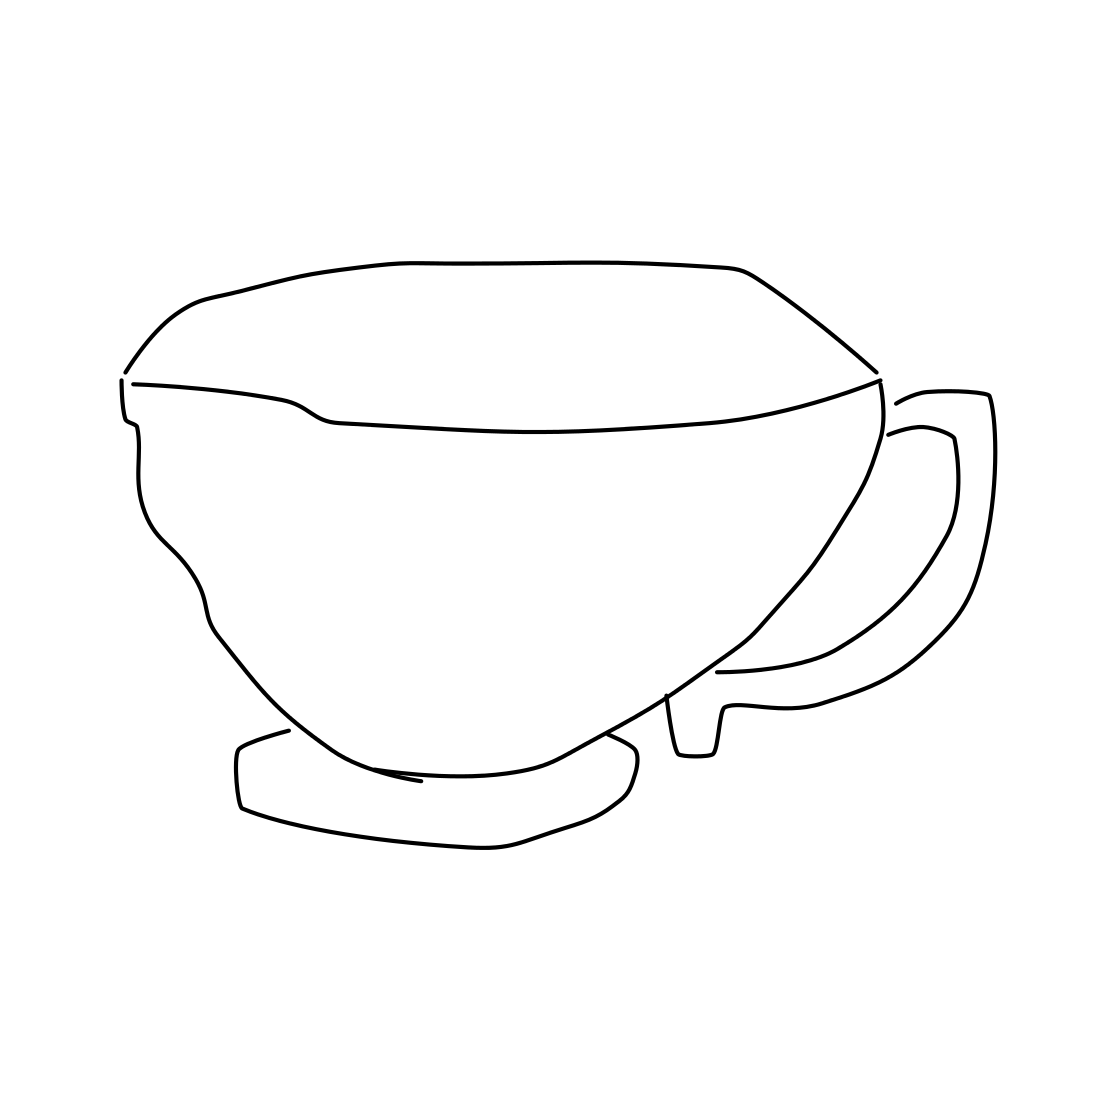In the scene, is a cup in it? Yes, there is a cup in the scene. It has a simple, elegant design, with a smooth, curved handle that suggests a comfortable grip. Its wide, open rim appears perfect for sipping your favorite beverage. 